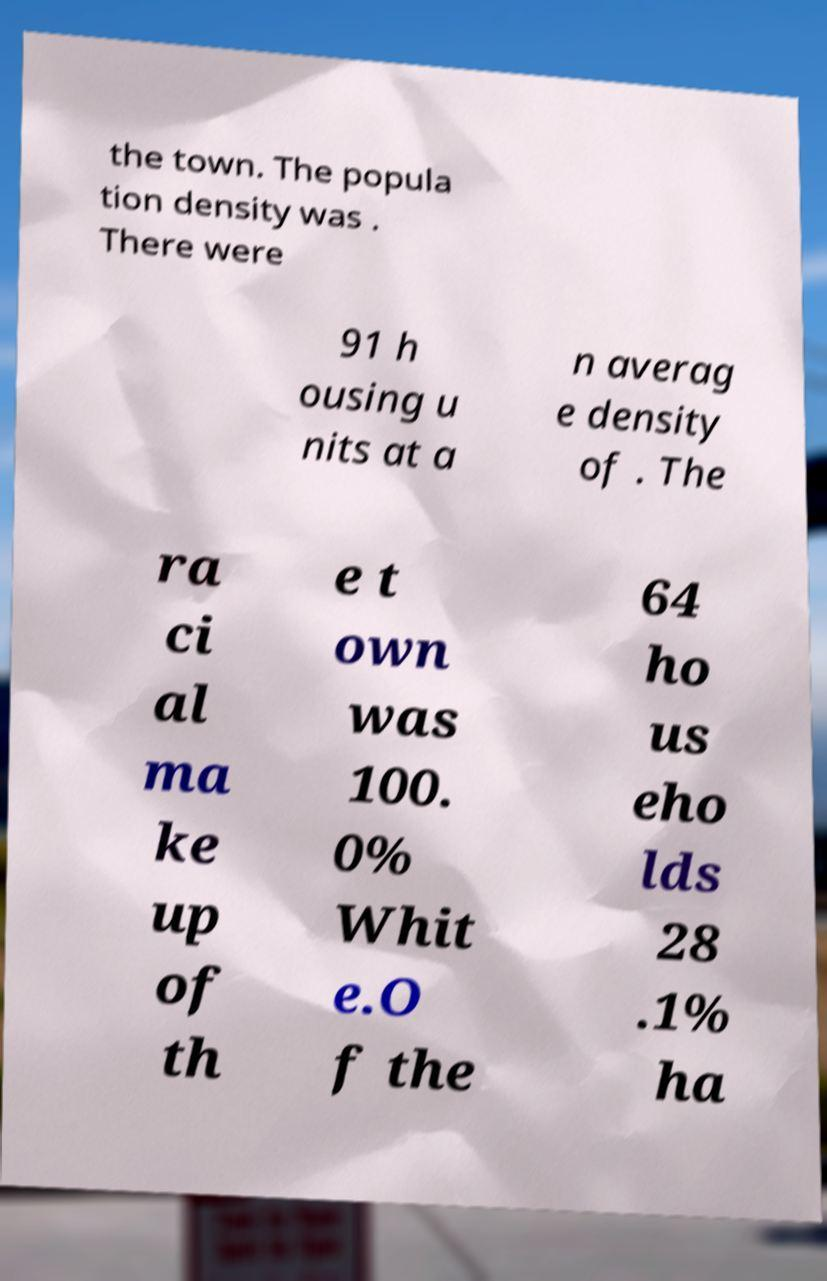There's text embedded in this image that I need extracted. Can you transcribe it verbatim? the town. The popula tion density was . There were 91 h ousing u nits at a n averag e density of . The ra ci al ma ke up of th e t own was 100. 0% Whit e.O f the 64 ho us eho lds 28 .1% ha 